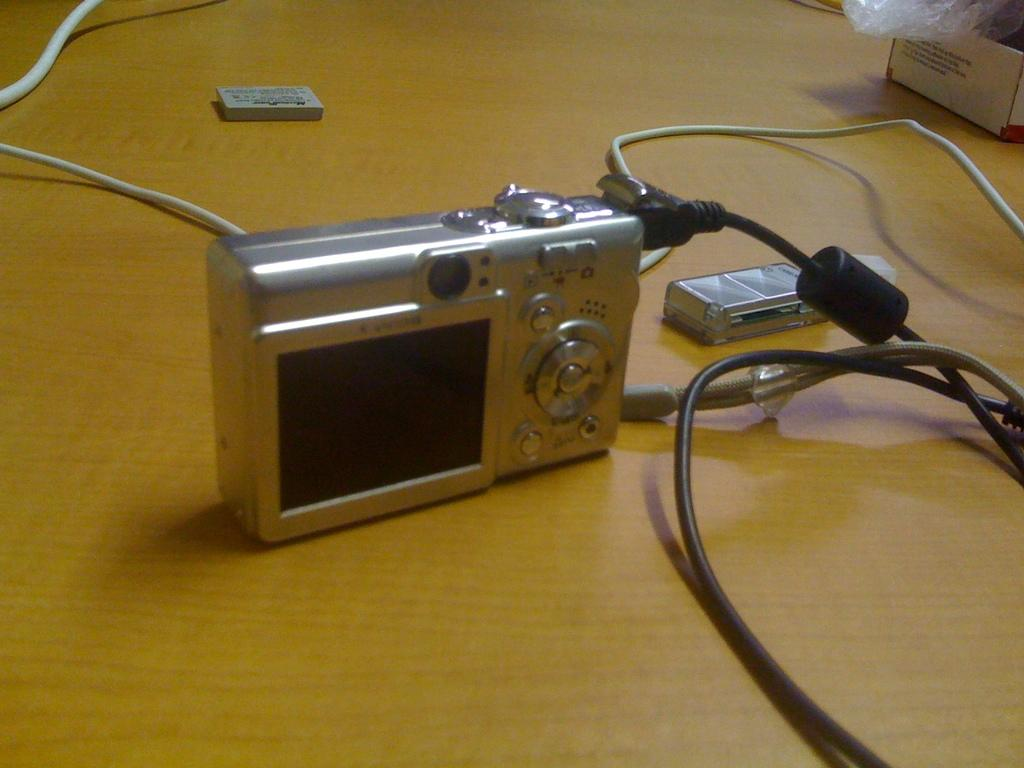What is the main object in the image? There is a camera in the image. What else can be seen in the image besides the camera? There are wires and a box in the image. Are there any other objects on the table in the image? Yes, there are other objects on the table in the image. What type of food is the rat eating in the image? There is no rat or food present in the image. Can you describe the sky in the image? The provided facts do not mention the sky, so it cannot be described based on the information given. 